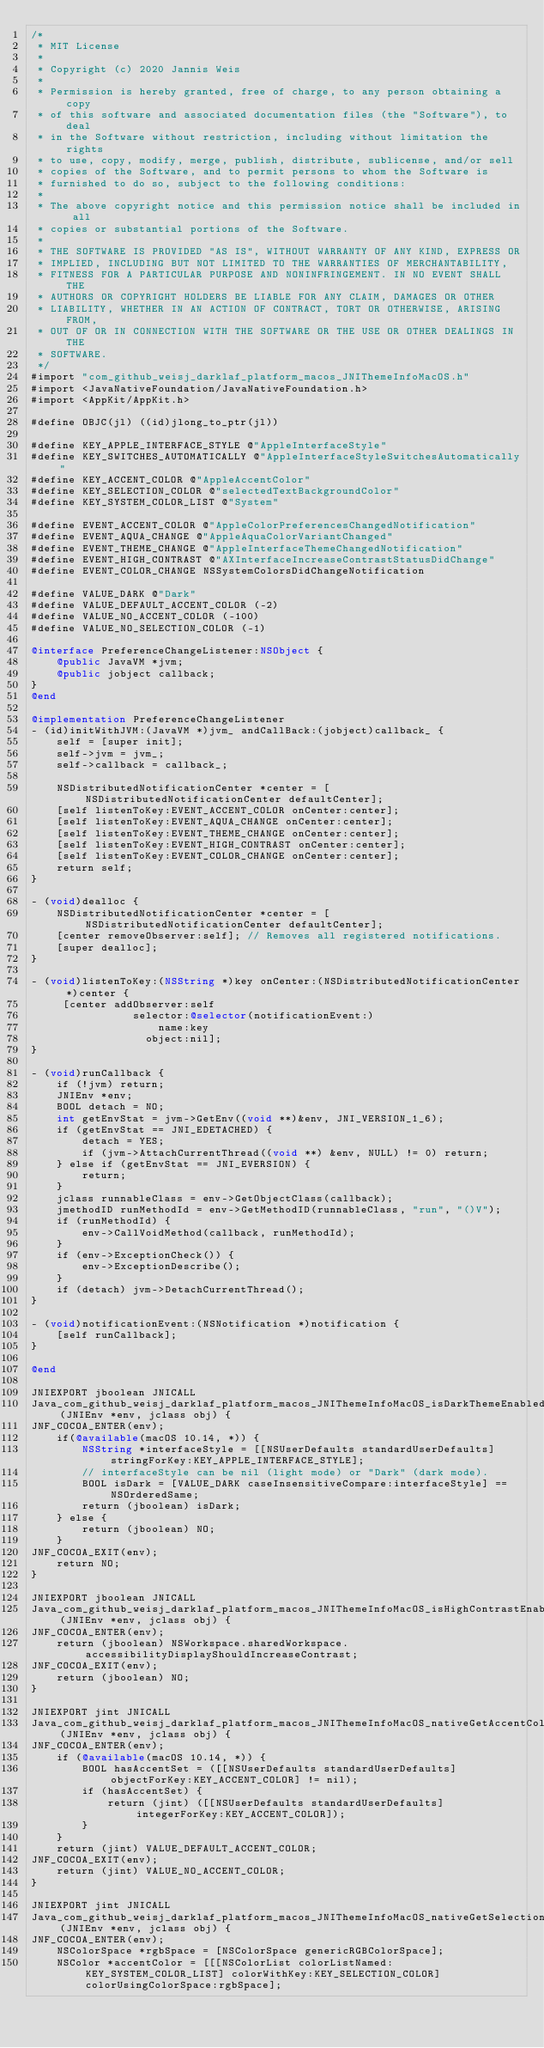<code> <loc_0><loc_0><loc_500><loc_500><_ObjectiveC_>/*
 * MIT License
 *
 * Copyright (c) 2020 Jannis Weis
 *
 * Permission is hereby granted, free of charge, to any person obtaining a copy
 * of this software and associated documentation files (the "Software"), to deal
 * in the Software without restriction, including without limitation the rights
 * to use, copy, modify, merge, publish, distribute, sublicense, and/or sell
 * copies of the Software, and to permit persons to whom the Software is
 * furnished to do so, subject to the following conditions:
 *
 * The above copyright notice and this permission notice shall be included in all
 * copies or substantial portions of the Software.
 *
 * THE SOFTWARE IS PROVIDED "AS IS", WITHOUT WARRANTY OF ANY KIND, EXPRESS OR
 * IMPLIED, INCLUDING BUT NOT LIMITED TO THE WARRANTIES OF MERCHANTABILITY,
 * FITNESS FOR A PARTICULAR PURPOSE AND NONINFRINGEMENT. IN NO EVENT SHALL THE
 * AUTHORS OR COPYRIGHT HOLDERS BE LIABLE FOR ANY CLAIM, DAMAGES OR OTHER
 * LIABILITY, WHETHER IN AN ACTION OF CONTRACT, TORT OR OTHERWISE, ARISING FROM,
 * OUT OF OR IN CONNECTION WITH THE SOFTWARE OR THE USE OR OTHER DEALINGS IN THE
 * SOFTWARE.
 */
#import "com_github_weisj_darklaf_platform_macos_JNIThemeInfoMacOS.h"
#import <JavaNativeFoundation/JavaNativeFoundation.h>
#import <AppKit/AppKit.h>

#define OBJC(jl) ((id)jlong_to_ptr(jl))

#define KEY_APPLE_INTERFACE_STYLE @"AppleInterfaceStyle"
#define KEY_SWITCHES_AUTOMATICALLY @"AppleInterfaceStyleSwitchesAutomatically"
#define KEY_ACCENT_COLOR @"AppleAccentColor"
#define KEY_SELECTION_COLOR @"selectedTextBackgroundColor"
#define KEY_SYSTEM_COLOR_LIST @"System"

#define EVENT_ACCENT_COLOR @"AppleColorPreferencesChangedNotification"
#define EVENT_AQUA_CHANGE @"AppleAquaColorVariantChanged"
#define EVENT_THEME_CHANGE @"AppleInterfaceThemeChangedNotification"
#define EVENT_HIGH_CONTRAST @"AXInterfaceIncreaseContrastStatusDidChange"
#define EVENT_COLOR_CHANGE NSSystemColorsDidChangeNotification

#define VALUE_DARK @"Dark"
#define VALUE_DEFAULT_ACCENT_COLOR (-2)
#define VALUE_NO_ACCENT_COLOR (-100)
#define VALUE_NO_SELECTION_COLOR (-1)

@interface PreferenceChangeListener:NSObject {
    @public JavaVM *jvm;
    @public jobject callback;
}
@end

@implementation PreferenceChangeListener
- (id)initWithJVM:(JavaVM *)jvm_ andCallBack:(jobject)callback_ {
    self = [super init];
    self->jvm = jvm_;
    self->callback = callback_;

    NSDistributedNotificationCenter *center = [NSDistributedNotificationCenter defaultCenter];
    [self listenToKey:EVENT_ACCENT_COLOR onCenter:center];
    [self listenToKey:EVENT_AQUA_CHANGE onCenter:center];
    [self listenToKey:EVENT_THEME_CHANGE onCenter:center];
    [self listenToKey:EVENT_HIGH_CONTRAST onCenter:center];
    [self listenToKey:EVENT_COLOR_CHANGE onCenter:center];
    return self;
}

- (void)dealloc {
    NSDistributedNotificationCenter *center = [NSDistributedNotificationCenter defaultCenter];
    [center removeObserver:self]; // Removes all registered notifications.
    [super dealloc];
}

- (void)listenToKey:(NSString *)key onCenter:(NSDistributedNotificationCenter *)center {
     [center addObserver:self
                selector:@selector(notificationEvent:)
                    name:key
                  object:nil];
}

- (void)runCallback {
    if (!jvm) return;
    JNIEnv *env;
    BOOL detach = NO;
    int getEnvStat = jvm->GetEnv((void **)&env, JNI_VERSION_1_6);
    if (getEnvStat == JNI_EDETACHED) {
        detach = YES;
        if (jvm->AttachCurrentThread((void **) &env, NULL) != 0) return;
    } else if (getEnvStat == JNI_EVERSION) {
        return;
    }
    jclass runnableClass = env->GetObjectClass(callback);
    jmethodID runMethodId = env->GetMethodID(runnableClass, "run", "()V");
    if (runMethodId) {
        env->CallVoidMethod(callback, runMethodId);
    }
    if (env->ExceptionCheck()) {
        env->ExceptionDescribe();
    }
    if (detach) jvm->DetachCurrentThread();
}

- (void)notificationEvent:(NSNotification *)notification {
    [self runCallback];
}

@end

JNIEXPORT jboolean JNICALL
Java_com_github_weisj_darklaf_platform_macos_JNIThemeInfoMacOS_isDarkThemeEnabled(JNIEnv *env, jclass obj) {
JNF_COCOA_ENTER(env);
    if(@available(macOS 10.14, *)) {
        NSString *interfaceStyle = [[NSUserDefaults standardUserDefaults] stringForKey:KEY_APPLE_INTERFACE_STYLE];
        // interfaceStyle can be nil (light mode) or "Dark" (dark mode).
        BOOL isDark = [VALUE_DARK caseInsensitiveCompare:interfaceStyle] == NSOrderedSame;
        return (jboolean) isDark;
    } else {
        return (jboolean) NO;
    }
JNF_COCOA_EXIT(env);
    return NO;
}

JNIEXPORT jboolean JNICALL
Java_com_github_weisj_darklaf_platform_macos_JNIThemeInfoMacOS_isHighContrastEnabled(JNIEnv *env, jclass obj) {
JNF_COCOA_ENTER(env);
    return (jboolean) NSWorkspace.sharedWorkspace.accessibilityDisplayShouldIncreaseContrast;
JNF_COCOA_EXIT(env);
    return (jboolean) NO;
}

JNIEXPORT jint JNICALL
Java_com_github_weisj_darklaf_platform_macos_JNIThemeInfoMacOS_nativeGetAccentColor(JNIEnv *env, jclass obj) {
JNF_COCOA_ENTER(env);
    if (@available(macOS 10.14, *)) {
        BOOL hasAccentSet = ([[NSUserDefaults standardUserDefaults] objectForKey:KEY_ACCENT_COLOR] != nil);
        if (hasAccentSet) {
            return (jint) ([[NSUserDefaults standardUserDefaults] integerForKey:KEY_ACCENT_COLOR]);
        }
    }
    return (jint) VALUE_DEFAULT_ACCENT_COLOR;
JNF_COCOA_EXIT(env);
    return (jint) VALUE_NO_ACCENT_COLOR;
}

JNIEXPORT jint JNICALL
Java_com_github_weisj_darklaf_platform_macos_JNIThemeInfoMacOS_nativeGetSelectionColor(JNIEnv *env, jclass obj) {
JNF_COCOA_ENTER(env);
    NSColorSpace *rgbSpace = [NSColorSpace genericRGBColorSpace];
    NSColor *accentColor = [[[NSColorList colorListNamed: KEY_SYSTEM_COLOR_LIST] colorWithKey:KEY_SELECTION_COLOR] colorUsingColorSpace:rgbSpace];</code> 